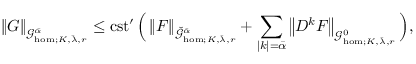<formula> <loc_0><loc_0><loc_500><loc_500>\left \| G \right \| _ { \mathcal { G } _ { h o m ; K , \bar { \lambda } , r } ^ { \bar { \alpha } } } \leq c s t ^ { \prime } \, \left ( \left \| F \right \| _ { \check { \mathcal { G } } _ { h o m ; K , \bar { \lambda } , r } ^ { \bar { \alpha } } } + \sum _ { | k | = \bar { \alpha } } \left \| D ^ { k } F \right \| _ { \mathcal { G } _ { h o m ; K , \bar { \lambda } , r } ^ { 0 } } \right ) ,</formula> 